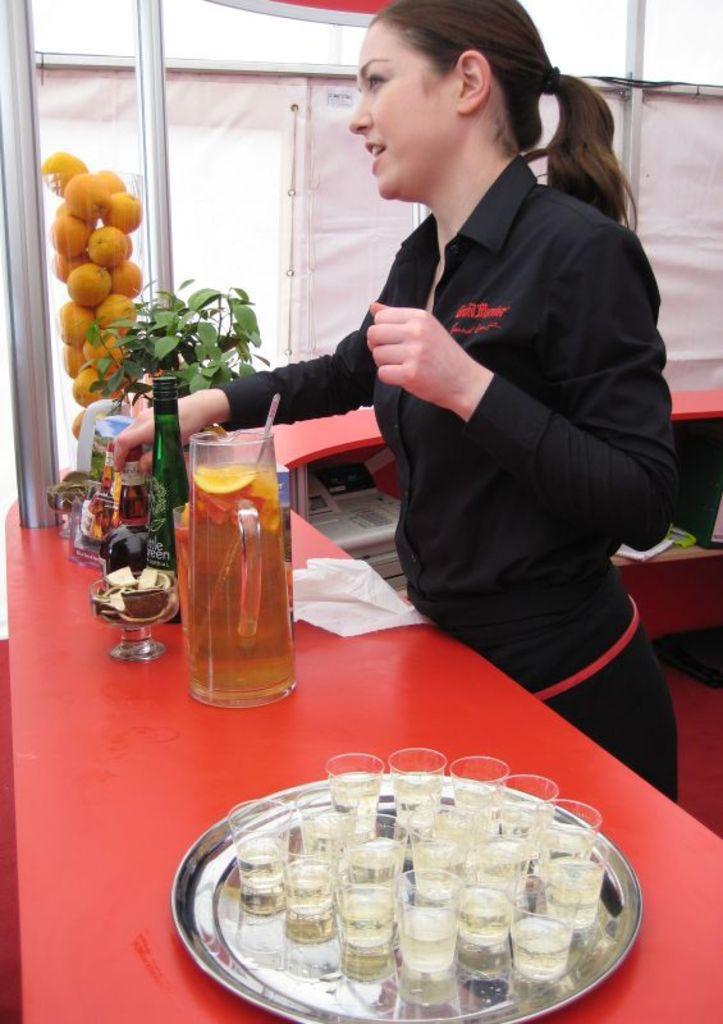Could you give a brief overview of what you see in this image? This picture consists of a woman , standing in front of a table , on the table I can see a plate , on the plate I can see glasses and jar contain a juice and a plant and fruits and spoons kept on table ,in the middle there is a white color fence and rods visible. 